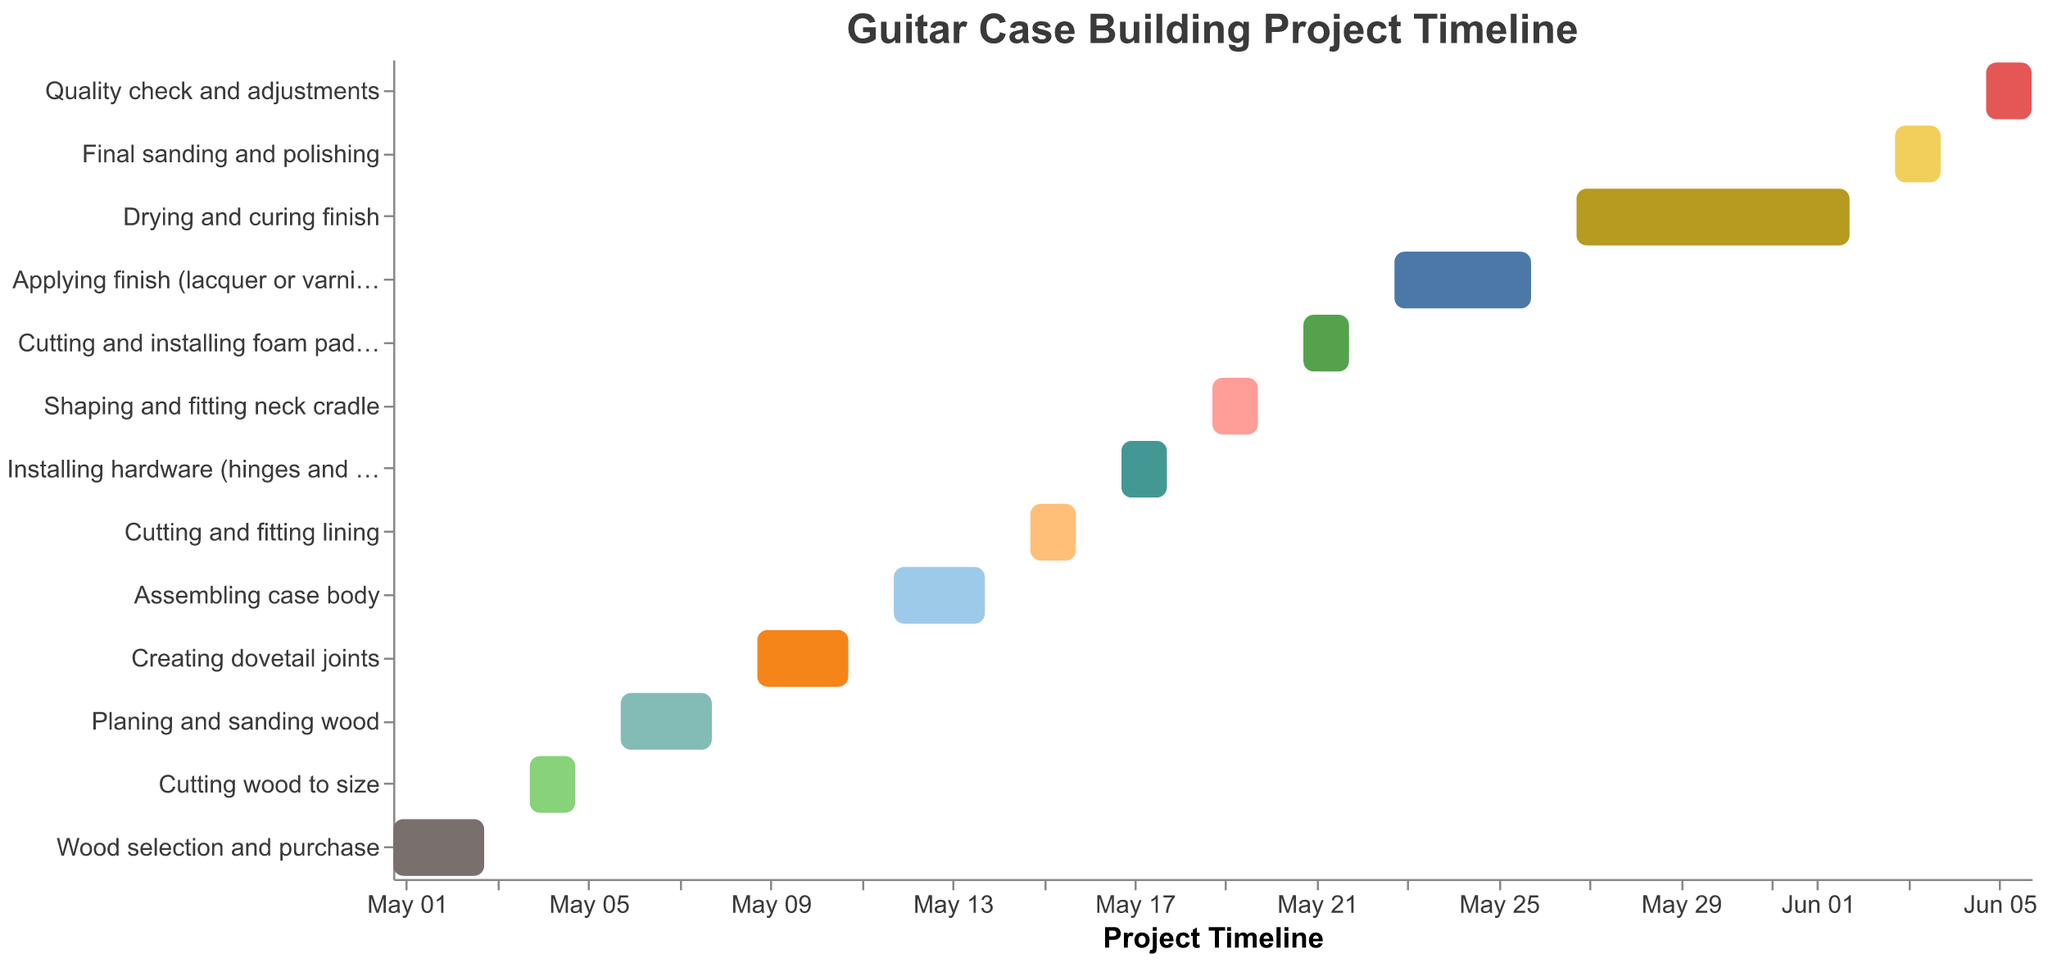What is the total duration for building the guitar case from start to finish? The project starts on 2023-05-01 and ends on 2023-06-06. The total duration is from May 1st to June 6th. By counting the days, we find it spans 37 days (inclusive).
Answer: 37 days Which task takes the longest time to complete? By examining the durations marked on the Gantt chart, the task "Drying and curing finish" spans from 2023-05-27 to 2023-06-02, which is 7 days. This is the longest duration compared to other tasks.
Answer: Drying and curing finish When does the final sanding and polishing start and end? The "Final sanding and polishing" task starts on 2023-06-03 and ends on 2023-06-04, as indicated on the Gantt chart.
Answer: Starts on 2023-06-03, ends on 2023-06-04 How many tasks are completed before "Installing hardware (hinges and latches)" begins? The task "Installing hardware (hinges and latches)" starts on 2023-05-17. The tasks completed before it are: "Wood selection and purchase", "Cutting wood to size", "Planing and sanding wood", "Creating dovetail joints", "Assembling case body", "Cutting and fitting lining". There are 6 tasks in total.
Answer: 6 tasks Which two tasks have the same duration? By checking the start and end dates, "Cutting wood to size" (2023-05-04 to 2023-05-05) and "Shaping and fitting neck cradle" (2023-05-19 to 2023-05-20) both take 2 days to complete.
Answer: Cutting wood to size, Shaping and fitting neck cradle What tasks are performed simultaneously with "Assembling case body"? The "Assembling case body" task is performed from 2023-05-12 to 2023-05-14. There are no other tasks that overlap with this time period on the chart.
Answer: None Between which two tasks is there the most considerable gap? After summarizing the timeline, the biggest gap is between "Drying and curing finish" (ends on 2023-06-02) and "Final sanding and polishing" (starts on 2023-06-03), where there is no gap at all. Hence, we need to check better presence of Task durations. Reviewing all there is no significant gap.
Answer: No considerable gap When does the task of "Quality check and adjustments" commence? The task of "Quality check and adjustments" commences on 2023-06-05, as seen on the Gantt chart.
Answer: 2023-06-05 What’s the total number of tasks in the project timeline? The Gantt chart lists all the tasks required to complete the guitar case project. Counting them, we find there are 13 tasks in total.
Answer: 13 tasks 